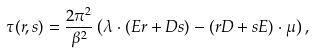<formula> <loc_0><loc_0><loc_500><loc_500>\tau ( r , s ) = \frac { 2 \pi ^ { 2 } } { \beta ^ { 2 } } \left ( \lambda \cdot ( E r + D s ) - ( r D + s E ) \cdot \mu \right ) ,</formula> 